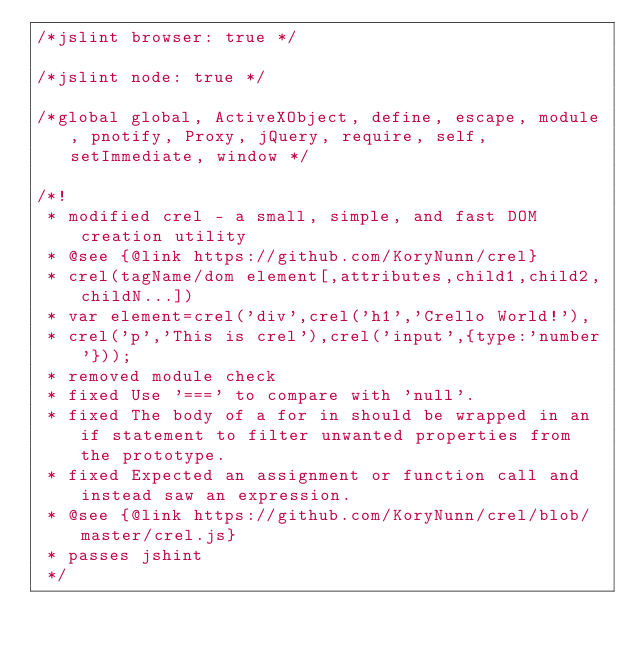<code> <loc_0><loc_0><loc_500><loc_500><_JavaScript_>/*jslint browser: true */

/*jslint node: true */

/*global global, ActiveXObject, define, escape, module, pnotify, Proxy, jQuery, require, self, setImmediate, window */

/*!
 * modified crel - a small, simple, and fast DOM creation utility
 * @see {@link https://github.com/KoryNunn/crel}
 * crel(tagName/dom element[,attributes,child1,child2,childN...])
 * var element=crel('div',crel('h1','Crello World!'),
 * crel('p','This is crel'),crel('input',{type:'number'}));
 * removed module check
 * fixed Use '===' to compare with 'null'.
 * fixed The body of a for in should be wrapped in an if statement to filter unwanted properties from the prototype.
 * fixed Expected an assignment or function call and instead saw an expression.
 * @see {@link https://github.com/KoryNunn/crel/blob/master/crel.js}
 * passes jshint
 */</code> 